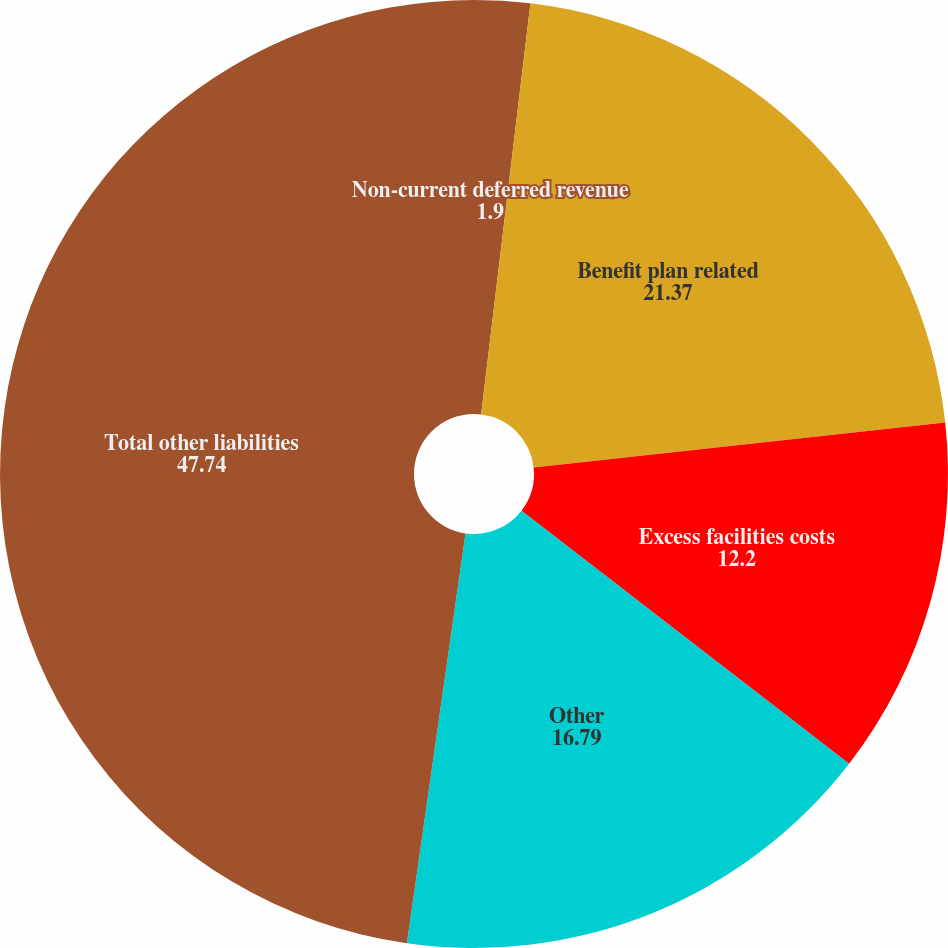Convert chart. <chart><loc_0><loc_0><loc_500><loc_500><pie_chart><fcel>Non-current deferred revenue<fcel>Benefit plan related<fcel>Excess facilities costs<fcel>Other<fcel>Total other liabilities<nl><fcel>1.9%<fcel>21.37%<fcel>12.2%<fcel>16.79%<fcel>47.74%<nl></chart> 